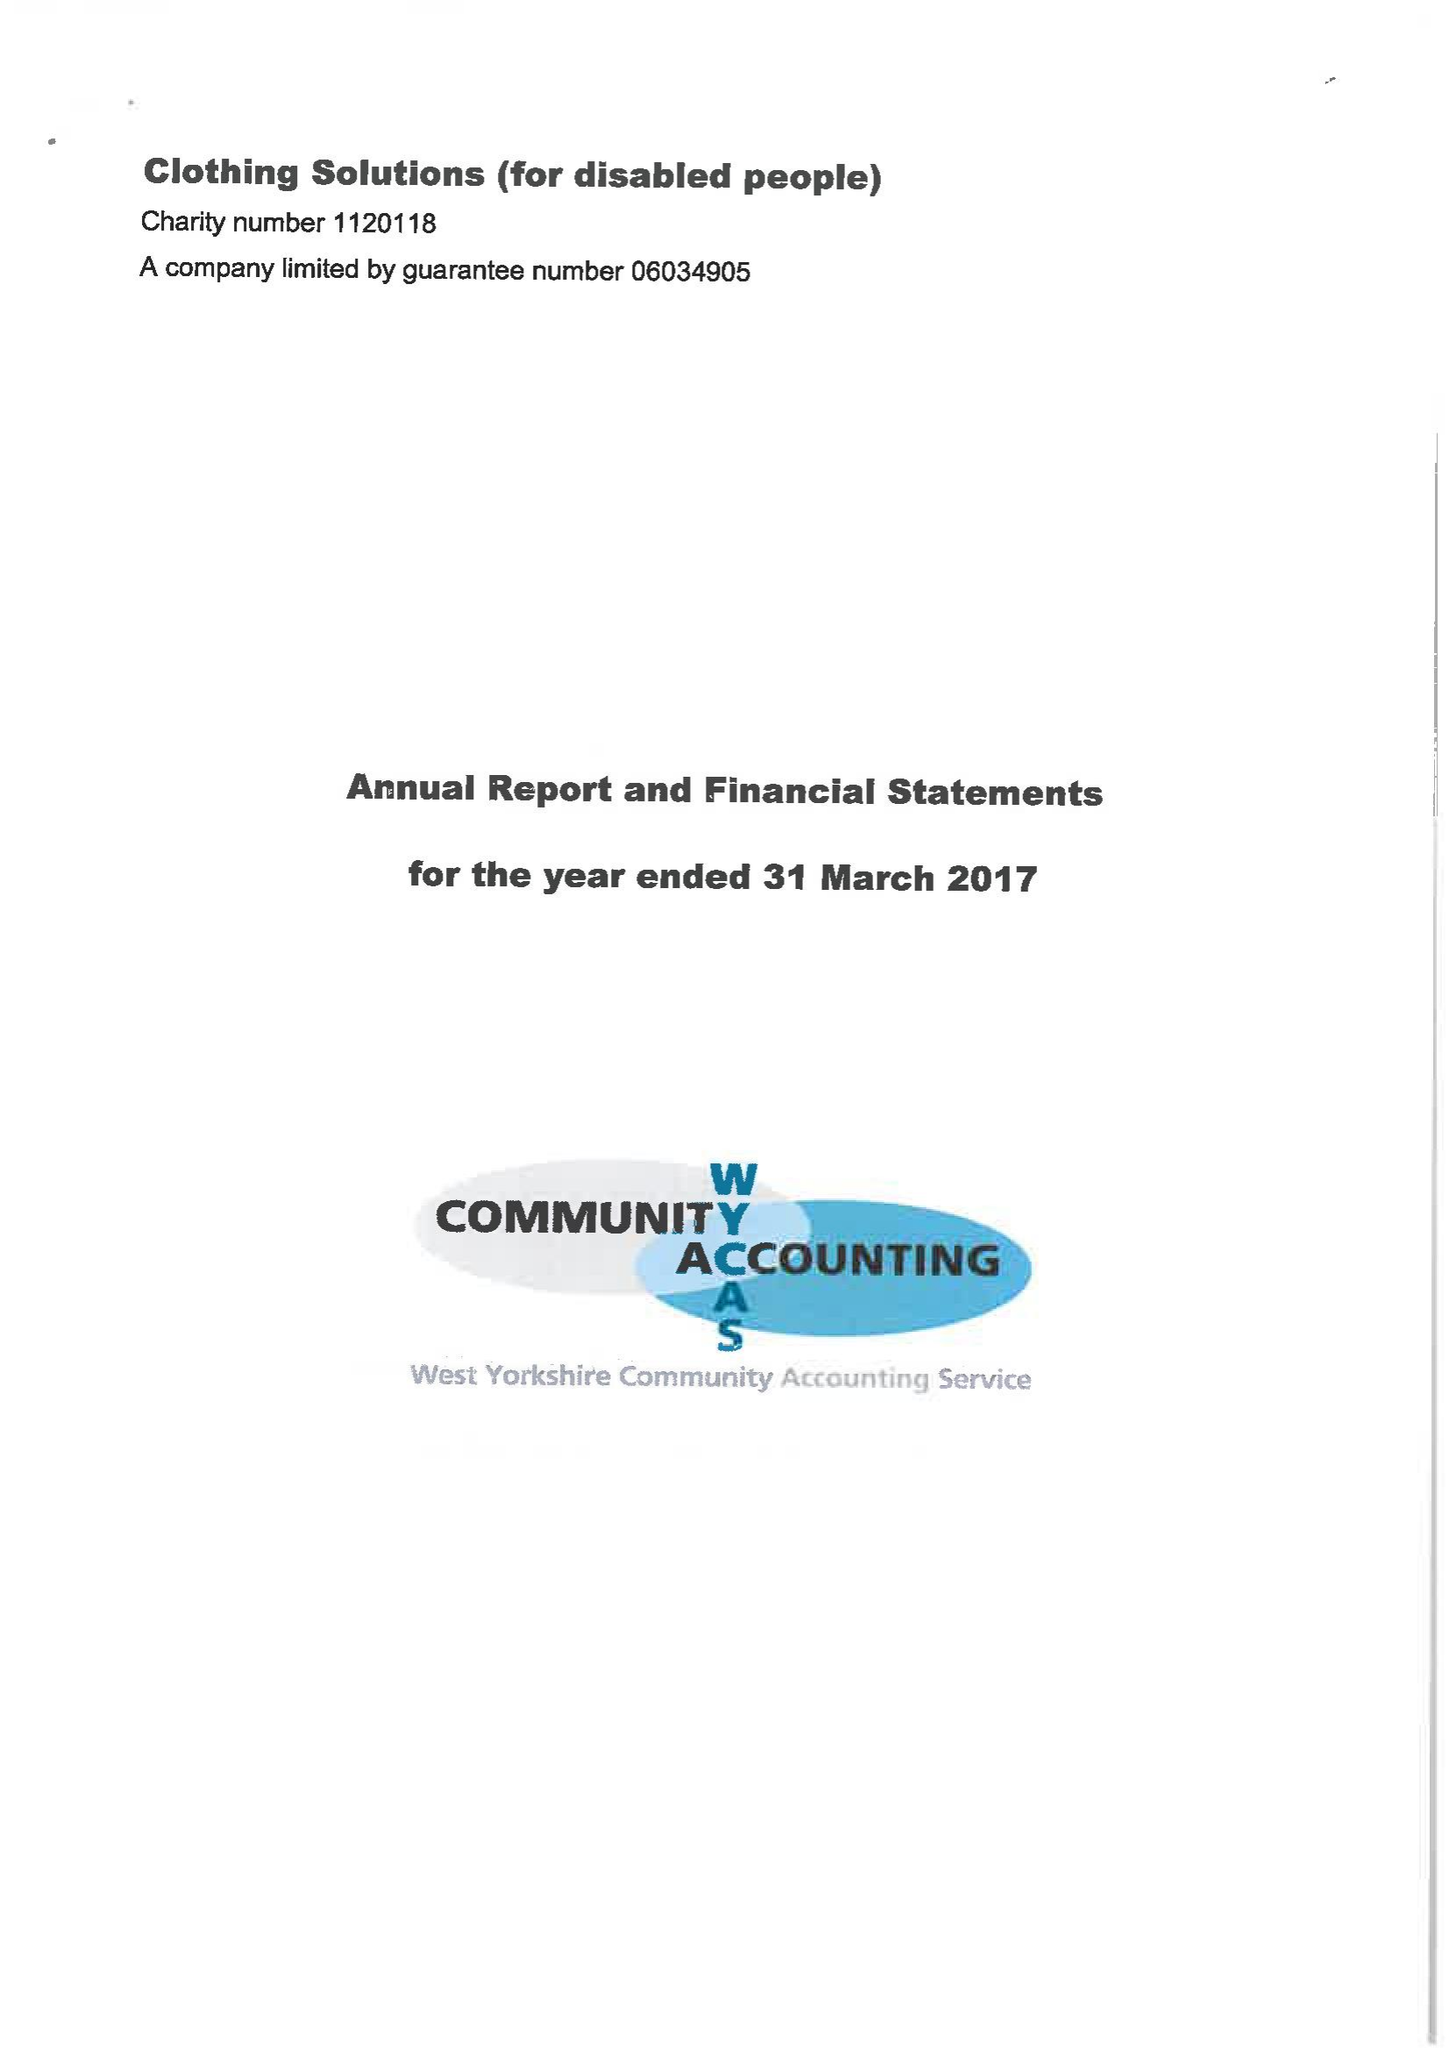What is the value for the charity_number?
Answer the question using a single word or phrase. 1120118 